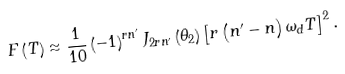Convert formula to latex. <formula><loc_0><loc_0><loc_500><loc_500>F \left ( T \right ) \approx \frac { 1 } { 1 0 } \left ( - 1 \right ) ^ { r n ^ { \prime } } J _ { 2 r n ^ { \prime } } \left ( \theta _ { 2 } \right ) \left [ r \left ( n ^ { \prime } - n \right ) \omega _ { d } T \right ] ^ { 2 } .</formula> 